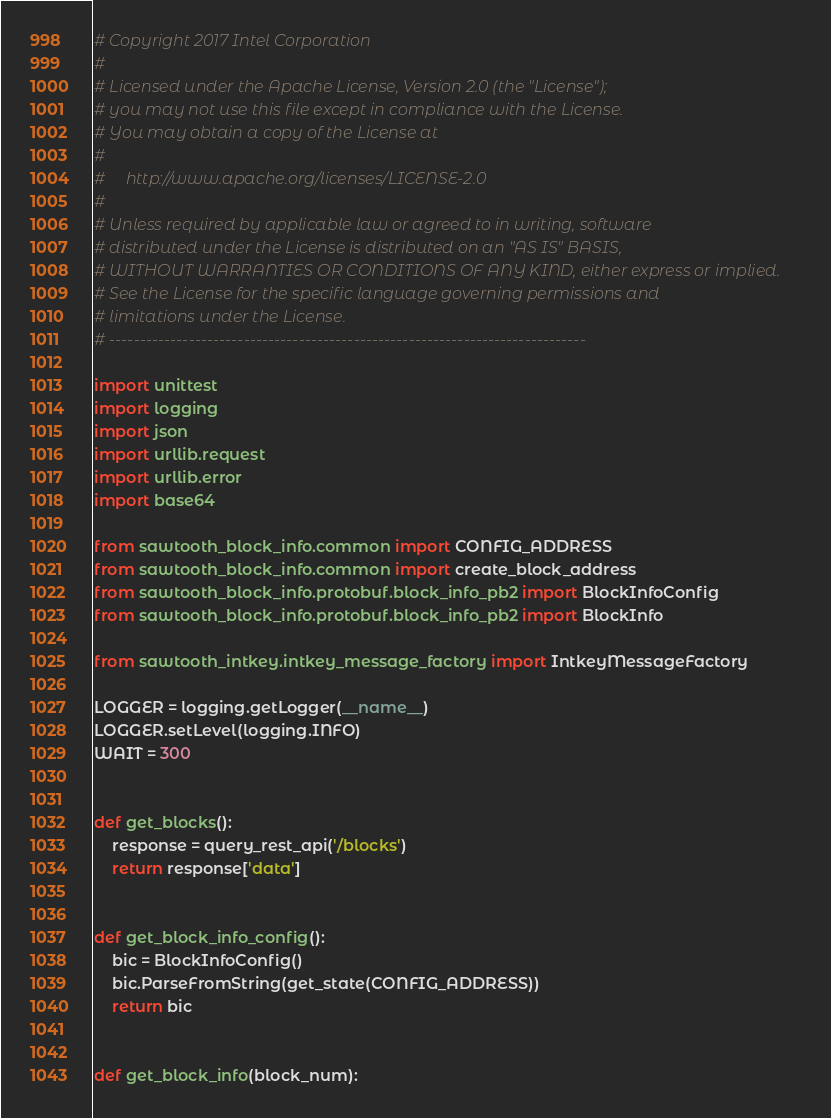<code> <loc_0><loc_0><loc_500><loc_500><_Python_># Copyright 2017 Intel Corporation
#
# Licensed under the Apache License, Version 2.0 (the "License");
# you may not use this file except in compliance with the License.
# You may obtain a copy of the License at
#
#     http://www.apache.org/licenses/LICENSE-2.0
#
# Unless required by applicable law or agreed to in writing, software
# distributed under the License is distributed on an "AS IS" BASIS,
# WITHOUT WARRANTIES OR CONDITIONS OF ANY KIND, either express or implied.
# See the License for the specific language governing permissions and
# limitations under the License.
# ------------------------------------------------------------------------------

import unittest
import logging
import json
import urllib.request
import urllib.error
import base64

from sawtooth_block_info.common import CONFIG_ADDRESS
from sawtooth_block_info.common import create_block_address
from sawtooth_block_info.protobuf.block_info_pb2 import BlockInfoConfig
from sawtooth_block_info.protobuf.block_info_pb2 import BlockInfo

from sawtooth_intkey.intkey_message_factory import IntkeyMessageFactory

LOGGER = logging.getLogger(__name__)
LOGGER.setLevel(logging.INFO)
WAIT = 300


def get_blocks():
    response = query_rest_api('/blocks')
    return response['data']


def get_block_info_config():
    bic = BlockInfoConfig()
    bic.ParseFromString(get_state(CONFIG_ADDRESS))
    return bic


def get_block_info(block_num):</code> 